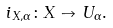<formula> <loc_0><loc_0><loc_500><loc_500>i _ { X , \alpha } \colon X \to U _ { \alpha } .</formula> 